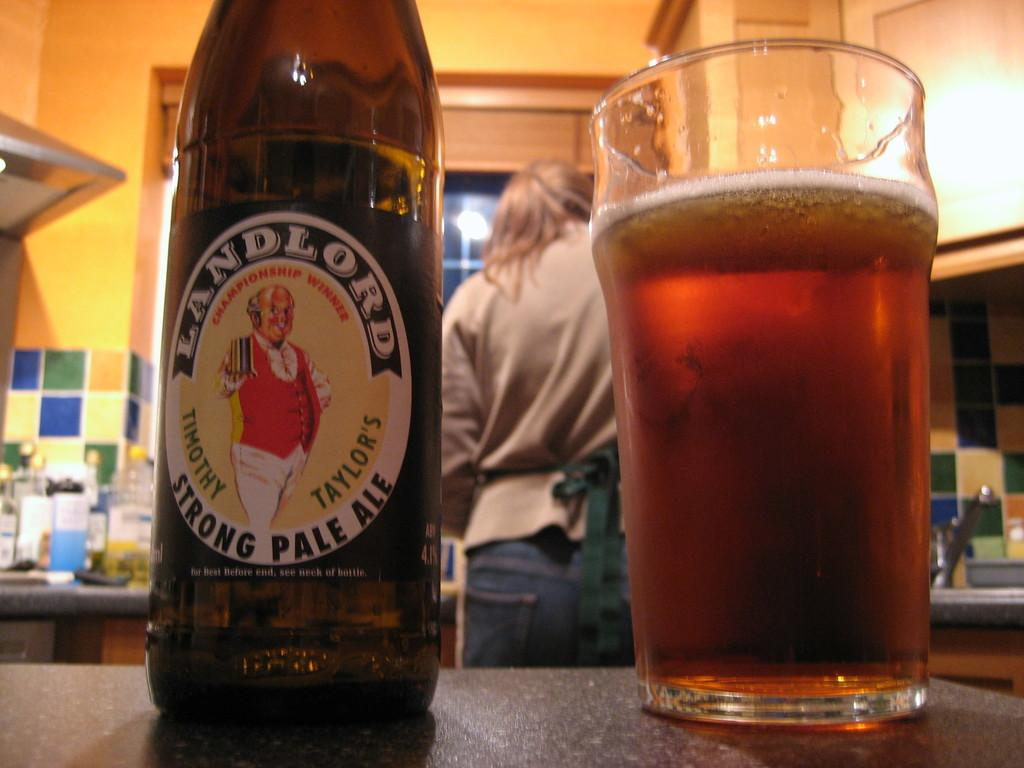<image>
Offer a succinct explanation of the picture presented. A bottle of Landlord Strong Pale Ale sits next to a pint glass. 